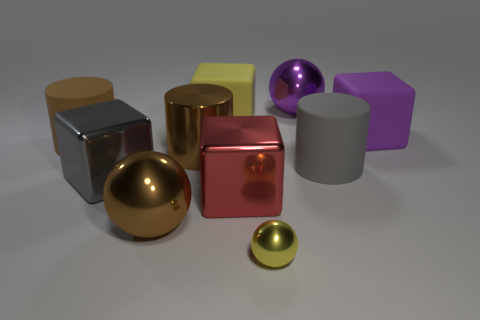The object that is behind the big matte thing behind the rubber cube that is in front of the yellow matte cube is made of what material?
Provide a succinct answer. Metal. Do the small shiny thing and the purple shiny thing have the same shape?
Provide a short and direct response. Yes. How many shiny things are both on the right side of the gray metallic object and behind the small metallic sphere?
Keep it short and to the point. 4. The rubber cylinder to the right of the large shiny cube that is on the right side of the yellow matte thing is what color?
Give a very brief answer. Gray. Are there the same number of purple rubber blocks behind the large purple rubber object and large green matte cylinders?
Offer a terse response. Yes. There is a gray thing to the left of the large ball that is behind the gray metal block; how many large spheres are behind it?
Keep it short and to the point. 1. There is a large cube on the left side of the large metallic cylinder; what is its color?
Your response must be concise. Gray. There is a big thing that is behind the large purple rubber thing and to the right of the small yellow metallic sphere; what material is it?
Give a very brief answer. Metal. There is a big matte cylinder that is to the right of the purple metallic thing; how many tiny yellow shiny objects are behind it?
Ensure brevity in your answer.  0. What is the shape of the gray metal thing?
Your response must be concise. Cube. 